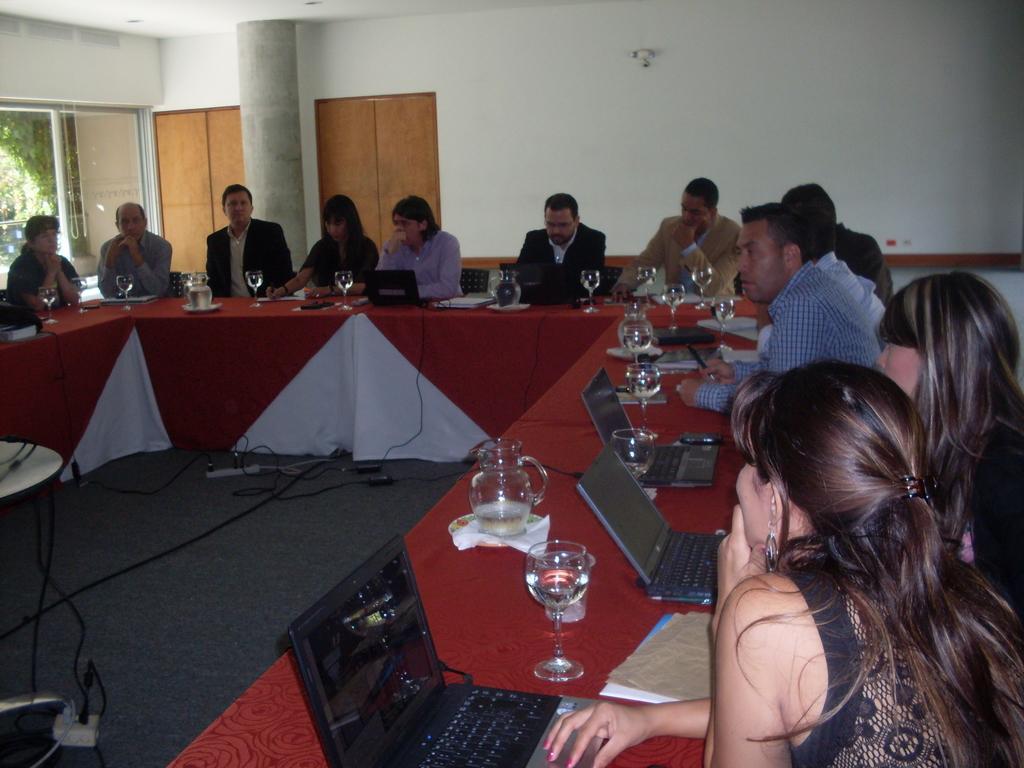Could you give a brief overview of what you see in this image? This image is clicked in a meeting room. Where there are so many tables arranged in a rectangular manner and this table consists of a jar ,many glasses ,laptops and so many people are sitting on chairs around this table, right side there are two women and left side there is one woman. There is a window on the left side and there is a pillar on the left side. There are so many wires placed in between the tables. There is a tissue under the jar ,there are books placed near a woman who is sitting right side. 